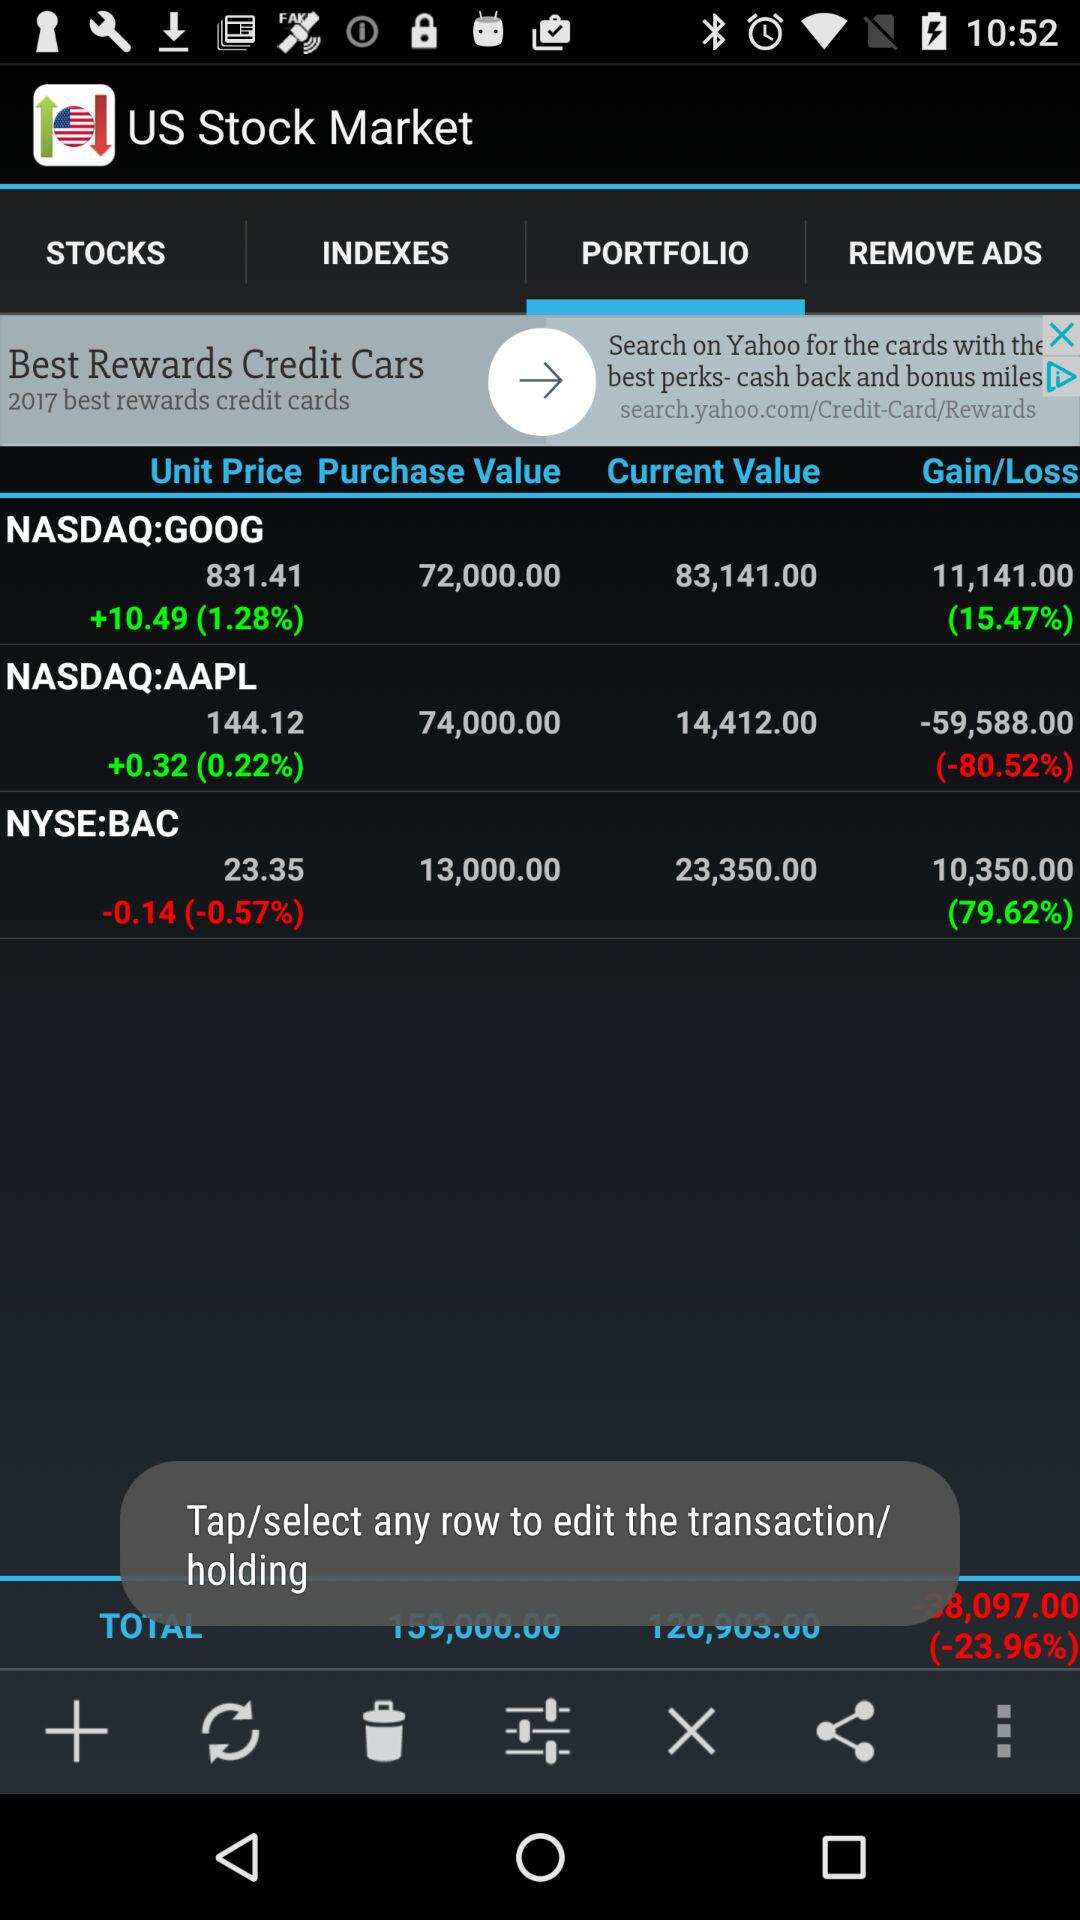What is the purchase value of BAC on the NYSE? The purchase value is 13,000. 